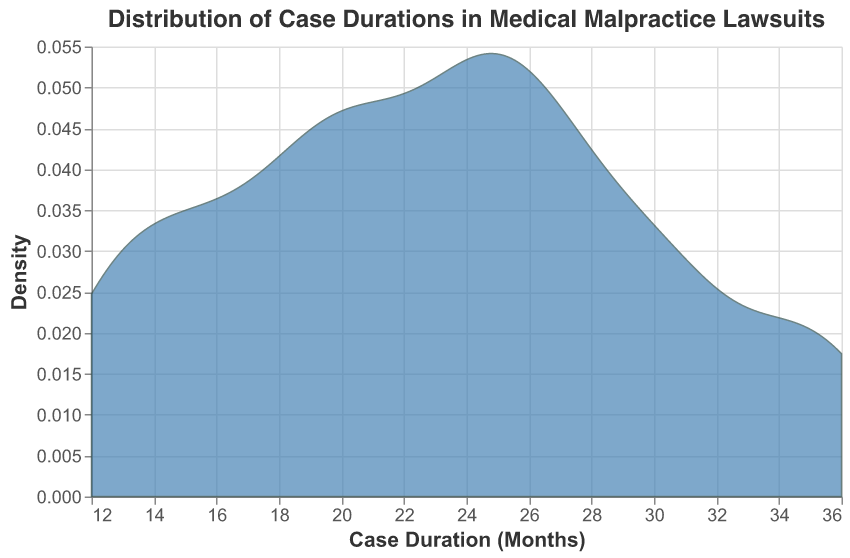what is the title of the figure? The text at the top of the figure specifies the title, which provides an overview of what the figure represents. The title reads "Distribution of Case Durations in Medical Malpractice Lawsuits". This tells us that the figure displays the distribution of the durations of various medical malpractice lawsuits.
Answer: Distribution of Case Durations in Medical Malpractice Lawsuits what is the range of case durations in months? The x-axis of the figure represents the case durations in months. The minimum and maximum ticks on the x-axis show the range of values. Observing the x-axis, we can see that the range goes from around 10 to 40 months.
Answer: Around 10 to 40 months what does the y-axis represent? The y-axis of the figure indicates density, which reveals how frequently certain case durations appear within the dataset. Density is often used in such plots to show the distribution of a continuous variable and its concentration.
Answer: Density what is the peak density value on the y-axis? Looking at the highest point on the y-axis and observing the plot, we find the peak where the density is the highest. This peak appears to be at around 0.05.
Answer: Around 0.05 at what case duration do we see the highest density? The x-coordinate where the density curve reaches its highest point indicates the case duration with the highest density. By identifying the position of the peak in the area chart, it looks like the highest density is around 24 months of case duration.
Answer: Around 24 months how many cases have durations less than 20 months? To answer this, we need to count the data points representing case durations below 20 months from the provided dataset. The cases are: Smith (18), Garcia (12), Gonzales (15), Taylor (16), Martin (13), Moore (19). Summing them up gives us a total of 6 cases.
Answer: 6 cases what is the average case duration? To calculate the average case duration, we sum all the case durations and divide by the number of cases. Summing up all case durations: 18 + 24 + 36 + 12 + 30 + 24 + 28 + 15 + 20 + 22 + 34 + 16 + 19 + 26 + 13 + 31 + 27 + 21 + 25 = 411. Dividing by the 19 cases: 411 / 19 ≈ 21.63 months.
Answer: 21.63 months which case has the shortest duration? Reviewing the dataset provided, we identify the case with the smallest duration value. Garcia v. St. Mary's Healthcare has the shortest duration at 12 months.
Answer: Garcia v. St. Mary's Healthcare which case has the longest duration? Checking the dataset for the largest duration value, we find Williams v. Riverside Clinic has the longest duration at 36 months.
Answer: Williams v. Riverside Clinic is the distribution of case durations skewed? if so, in which direction? Observing the overall shape of the distribution plot, we can identify the skewness. Since the peak density is closer to the left side, and the tail extends further to the right, the distribution appears to be right-skewed or positively skewed.
Answer: Right-skewed 